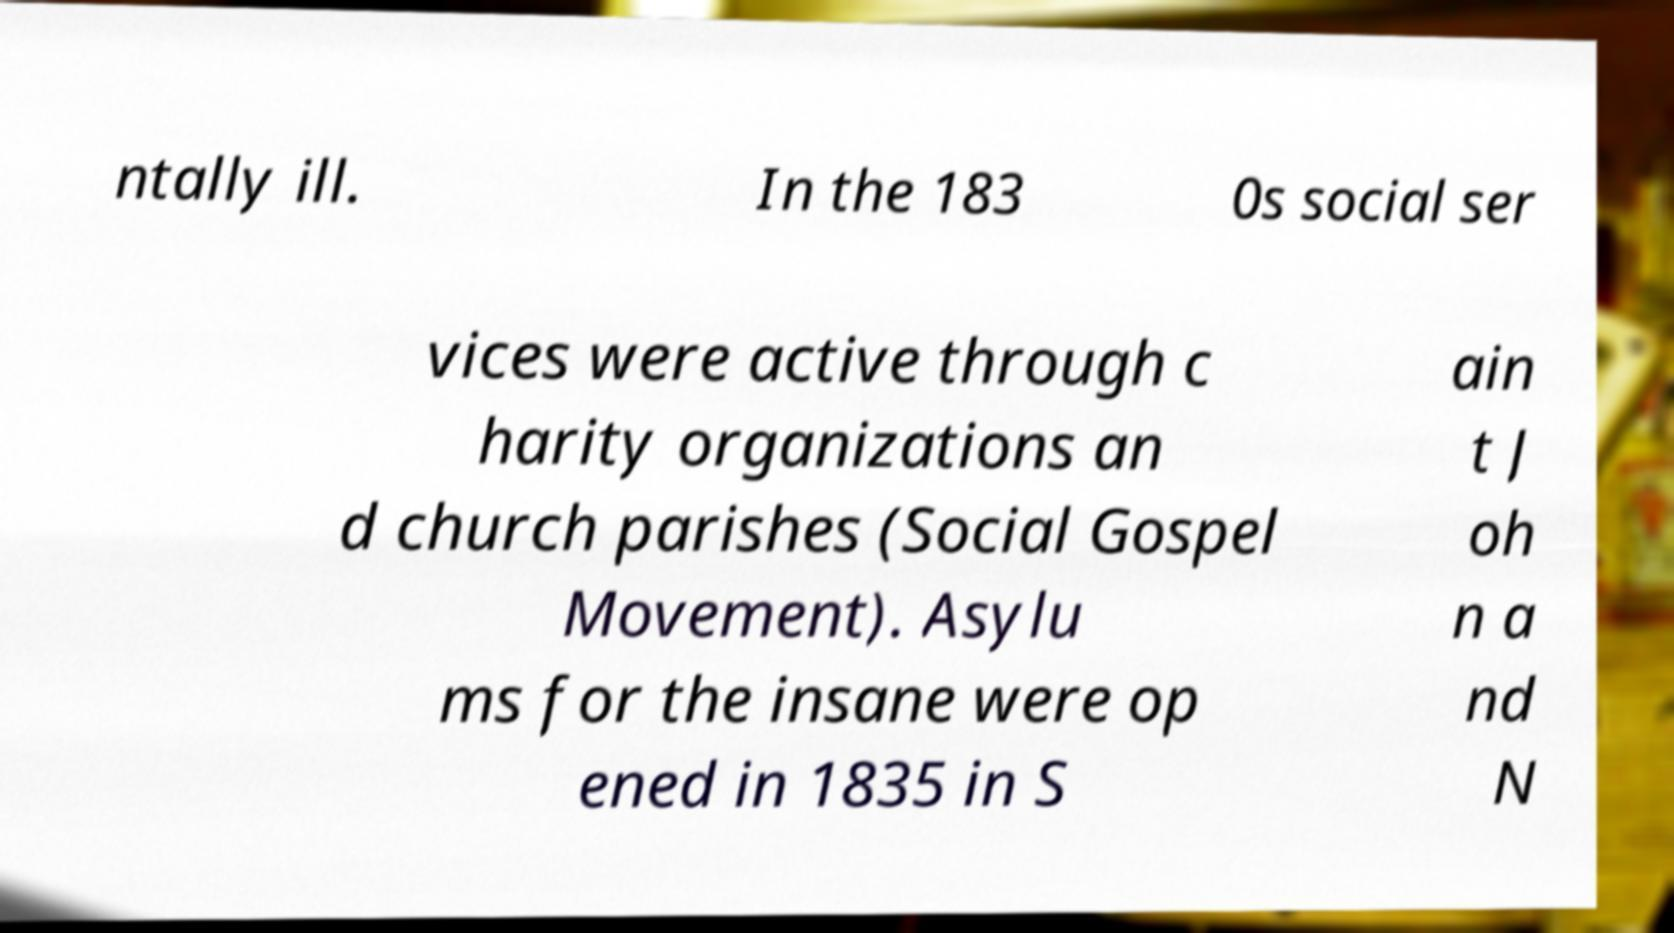Could you extract and type out the text from this image? ntally ill. In the 183 0s social ser vices were active through c harity organizations an d church parishes (Social Gospel Movement). Asylu ms for the insane were op ened in 1835 in S ain t J oh n a nd N 